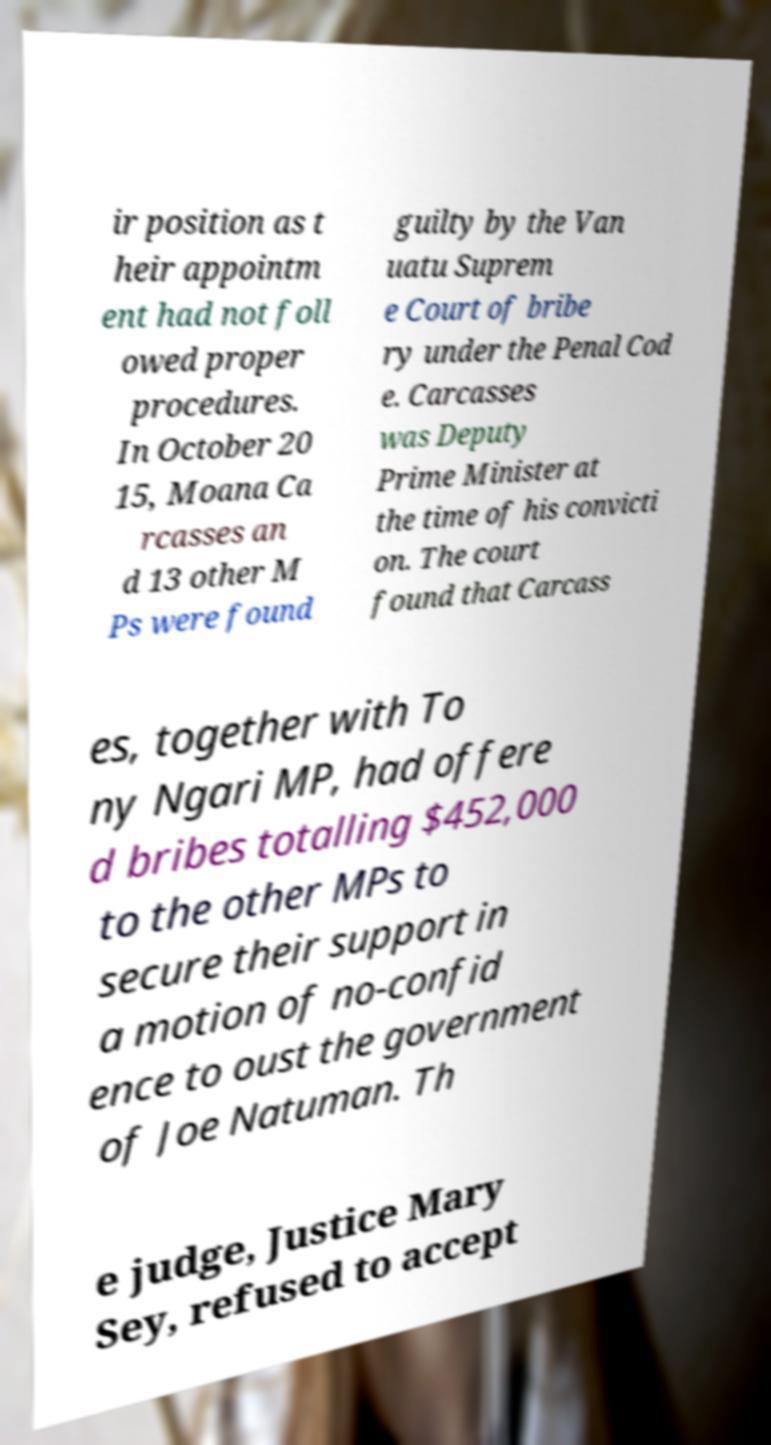Please identify and transcribe the text found in this image. ir position as t heir appointm ent had not foll owed proper procedures. In October 20 15, Moana Ca rcasses an d 13 other M Ps were found guilty by the Van uatu Suprem e Court of bribe ry under the Penal Cod e. Carcasses was Deputy Prime Minister at the time of his convicti on. The court found that Carcass es, together with To ny Ngari MP, had offere d bribes totalling $452,000 to the other MPs to secure their support in a motion of no-confid ence to oust the government of Joe Natuman. Th e judge, Justice Mary Sey, refused to accept 